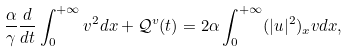<formula> <loc_0><loc_0><loc_500><loc_500>\frac { \alpha } { \gamma } \frac { d } { d t } \int _ { 0 } ^ { + \infty } v ^ { 2 } d x + \mathcal { Q } ^ { v } ( t ) = 2 \alpha \int _ { 0 } ^ { + \infty } ( | u | ^ { 2 } ) _ { x } v d x ,</formula> 